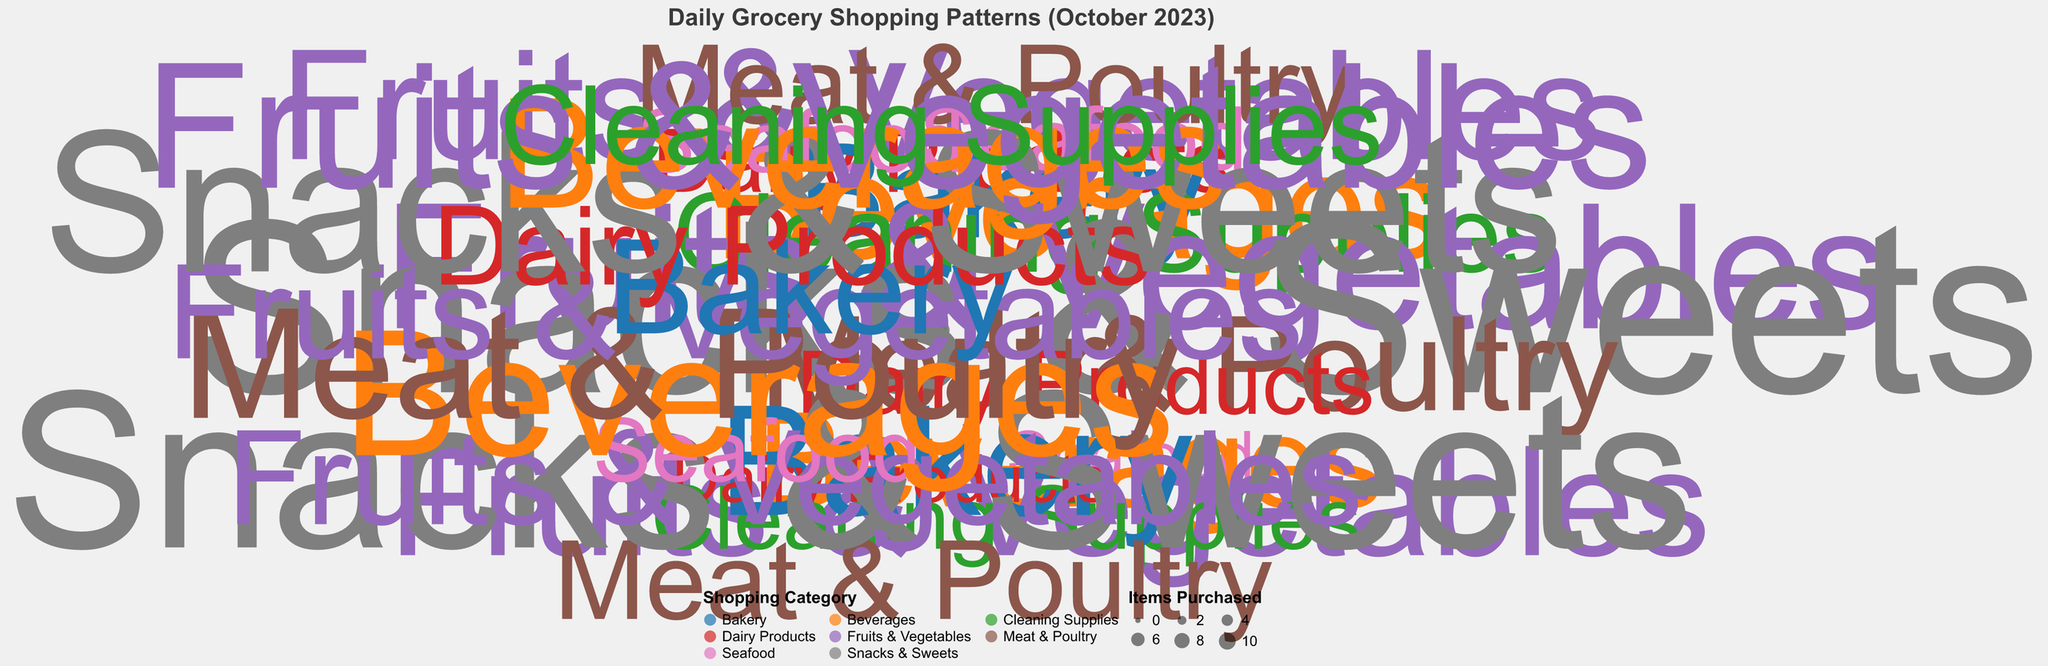What are the different categories of shopping mentioned in the chart? The chart uses color to represent different shopping categories such as "Fruits & Vegetables," "Dairy Products," etc. By identifying all the different colors and corresponding legends, we can list the categories.
Answer: Fruits & Vegetables, Dairy Products, Meat & Poultry, Bakery, Seafood, Beverages, Cleaning Supplies, Snacks & Sweets Which shopping category has the highest number of items purchased on any given day? By observing the size of the points, the largest points indicate the highest number of items purchased. The size and label details around the largest points show the shopping category and corresponding date.
Answer: Snacks & Sweets How much was spent on fruits and vegetables on October 20th? Locate the point corresponding to the date "2023-10-20" and verify the color that represents "Fruits & Vegetables." Check the associated radial distance from the center to determine the amount spent.
Answer: 1450 JPY On which day was the least amount spent on bakery items? Identify the points corresponding to "Bakery" by their specific color. Then, find the point closest to the center of the polar plot for the "Bakery" category.
Answer: October 25 Which category had the highest total expenditure in October? Sum the amounts spent in each category by locating all the points associated with each category’s color and adding those amounts together. The category with the highest sum is the answer.
Answer: Meat & Poultry Are there any days when the amount spent on beverages and cleaning supplies was the same? Observe the polar chart for points corresponding to "Beverages" and "Cleaning Supplies" and compare their radial distances to find any equivalence.
Answer: October 31 On average, how many items were purchased per day in the "Meat & Poultry" category? Identify all points corresponding to "Meat & Poultry," count the number of items purchased each day, sum these values, and then divide by the number of points (days).
Answer: 4.6 items/day Compare the total amount spent on "Seafood" versus "Beverages" throughout the month. Which is higher? Sum the expenditure for each category by finding all relevant points and adding their amounts. Compare the total amounts to determine which is higher.
Answer: Beverages How many times did grocery shopping occur in the entire month? Count the total number of points on the plot, as each point represents a day when shopping was done.
Answer: 31 What pattern can be observed in the spending on "Fruits & Vegetables" over the month? Identify points corresponding to "Fruits & Vegetables" and observe any changes in the radius over the month to determine if there is an increasing or decreasing trend or variability.
Answer: Variable spending, no clear trend 